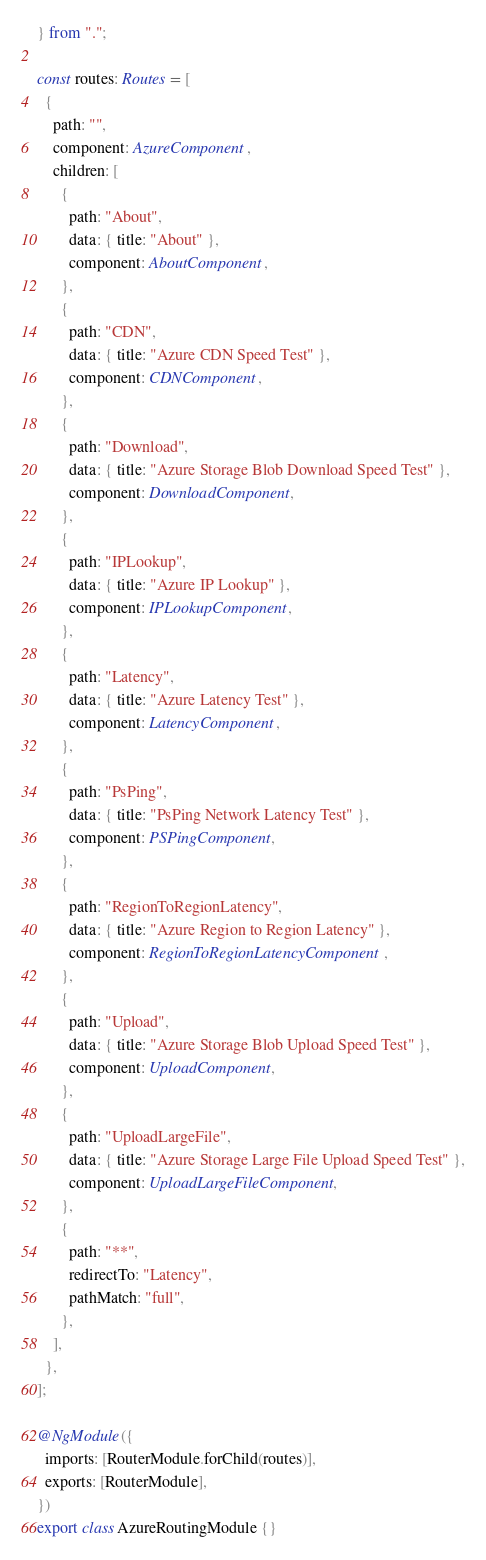<code> <loc_0><loc_0><loc_500><loc_500><_TypeScript_>} from ".";

const routes: Routes = [
  {
    path: "",
    component: AzureComponent,
    children: [
      {
        path: "About",
        data: { title: "About" },
        component: AboutComponent,
      },
      {
        path: "CDN",
        data: { title: "Azure CDN Speed Test" },
        component: CDNComponent,
      },
      {
        path: "Download",
        data: { title: "Azure Storage Blob Download Speed Test" },
        component: DownloadComponent,
      },
      {
        path: "IPLookup",
        data: { title: "Azure IP Lookup" },
        component: IPLookupComponent,
      },
      {
        path: "Latency",
        data: { title: "Azure Latency Test" },
        component: LatencyComponent,
      },
      {
        path: "PsPing",
        data: { title: "PsPing Network Latency Test" },
        component: PSPingComponent,
      },
      {
        path: "RegionToRegionLatency",
        data: { title: "Azure Region to Region Latency" },
        component: RegionToRegionLatencyComponent,
      },
      {
        path: "Upload",
        data: { title: "Azure Storage Blob Upload Speed Test" },
        component: UploadComponent,
      },
      {
        path: "UploadLargeFile",
        data: { title: "Azure Storage Large File Upload Speed Test" },
        component: UploadLargeFileComponent,
      },
      {
        path: "**",
        redirectTo: "Latency",
        pathMatch: "full",
      },
    ],
  },
];

@NgModule({
  imports: [RouterModule.forChild(routes)],
  exports: [RouterModule],
})
export class AzureRoutingModule {}
</code> 